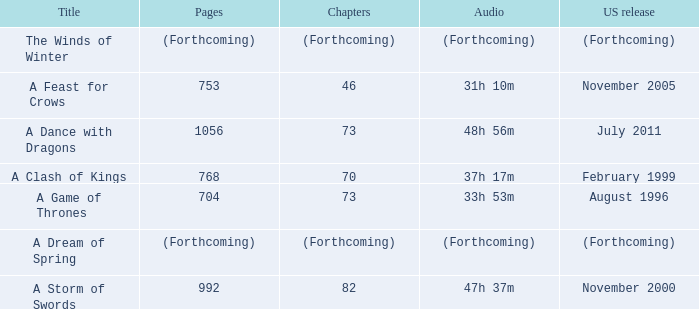Which US release has 704 pages? August 1996. 